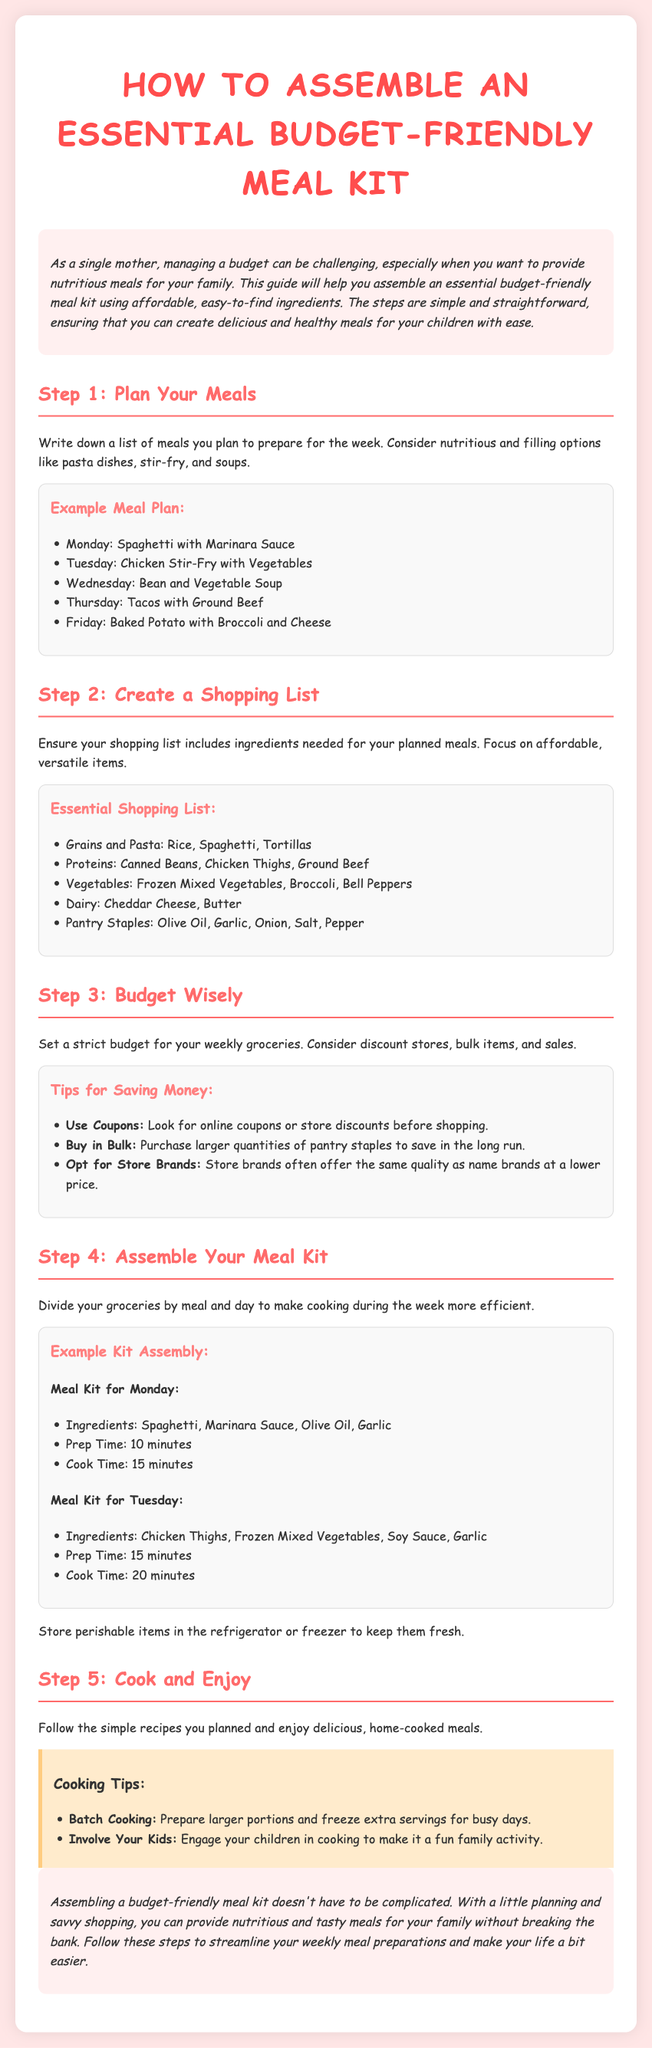What is the title of the guide? The title of the guide is displayed in the header section of the document, which states "How to Assemble an Essential Budget-Friendly Meal Kit."
Answer: How to Assemble an Essential Budget-Friendly Meal Kit What is included in the essential shopping list? The shopping list contains specific items categorized into grains, proteins, vegetables, dairy, and pantry staples.
Answer: Rice, Spaghetti, Tortillas, Canned Beans, Chicken Thighs, Ground Beef, Frozen Mixed Vegetables, Broccoli, Bell Peppers, Cheddar Cheese, Butter, Olive Oil, Garlic, Onion, Salt, Pepper How many meals are planned for the week? The document lists five meals planned for the week in the example meal plan.
Answer: Five What is the prep time for Monday's meal? The prep time for Monday’s meal (Spaghetti with Marinara Sauce) is clearly stated in the example kit assembly section of the document.
Answer: 10 minutes What are two tips for saving money while shopping? The document provides specific tips within a section, focusing on strategies that help cut costs while shopping.
Answer: Use Coupons, Buy in Bulk What should be considered when planning meals according to the guide? The guide emphasizes the importance of choosing meals that are nutritious and filling when planning.
Answer: Nutritious and filling options How are perishable items recommended to be stored? The document advises to store perishable items in a specific location to ensure their freshness.
Answer: Refrigerator or freezer What is a suggested cooking tip provided in the document? The document lists a cooking tip that encourages an efficient practice related to meal preparations.
Answer: Batch Cooking What is the color of the background mentioned in the introduction? The introductory section mentions the background color that creates a warm atmosphere.
Answer: #ffe6e6 